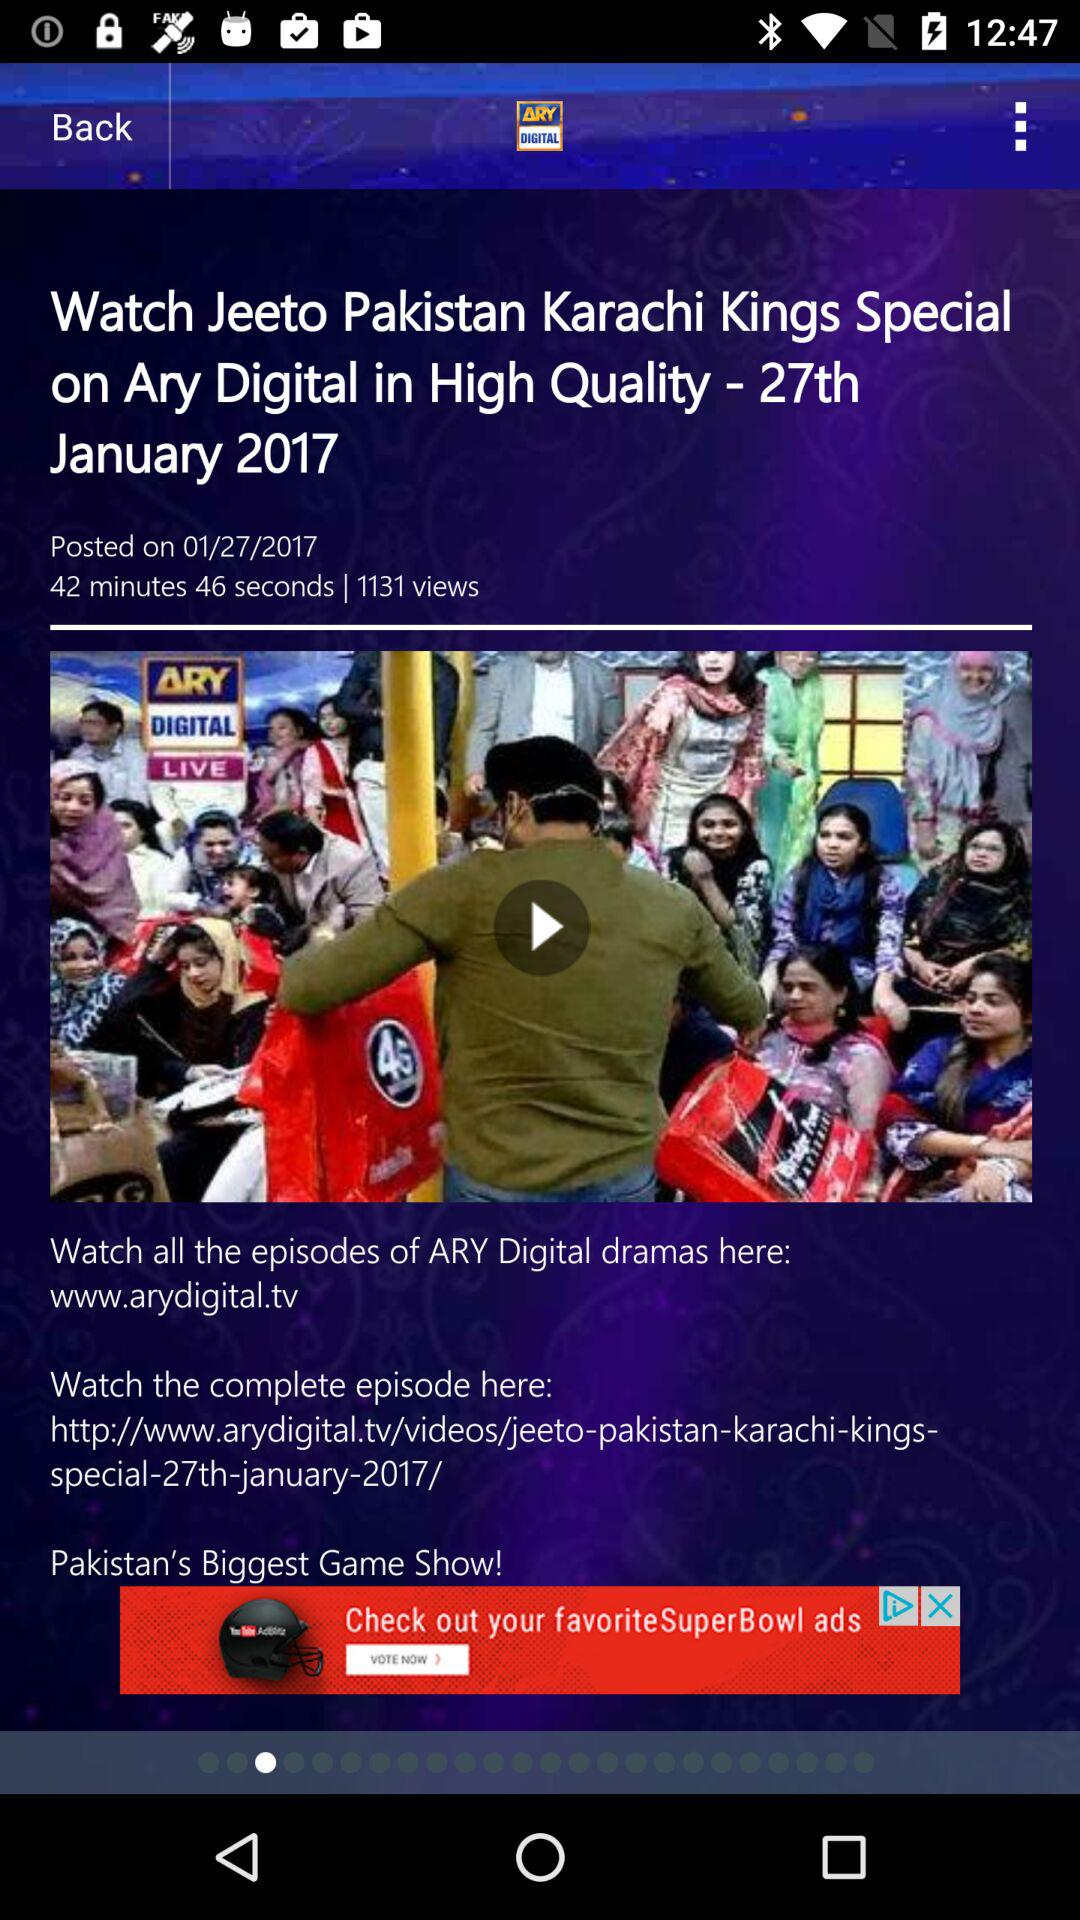What is the duration of the drama named "Jeeto Pakistan Karachi Kings Special"? The duration of the drama named "Jeeto Pakistan Karachi Kings Special" is 42 minutes 46 seconds. 